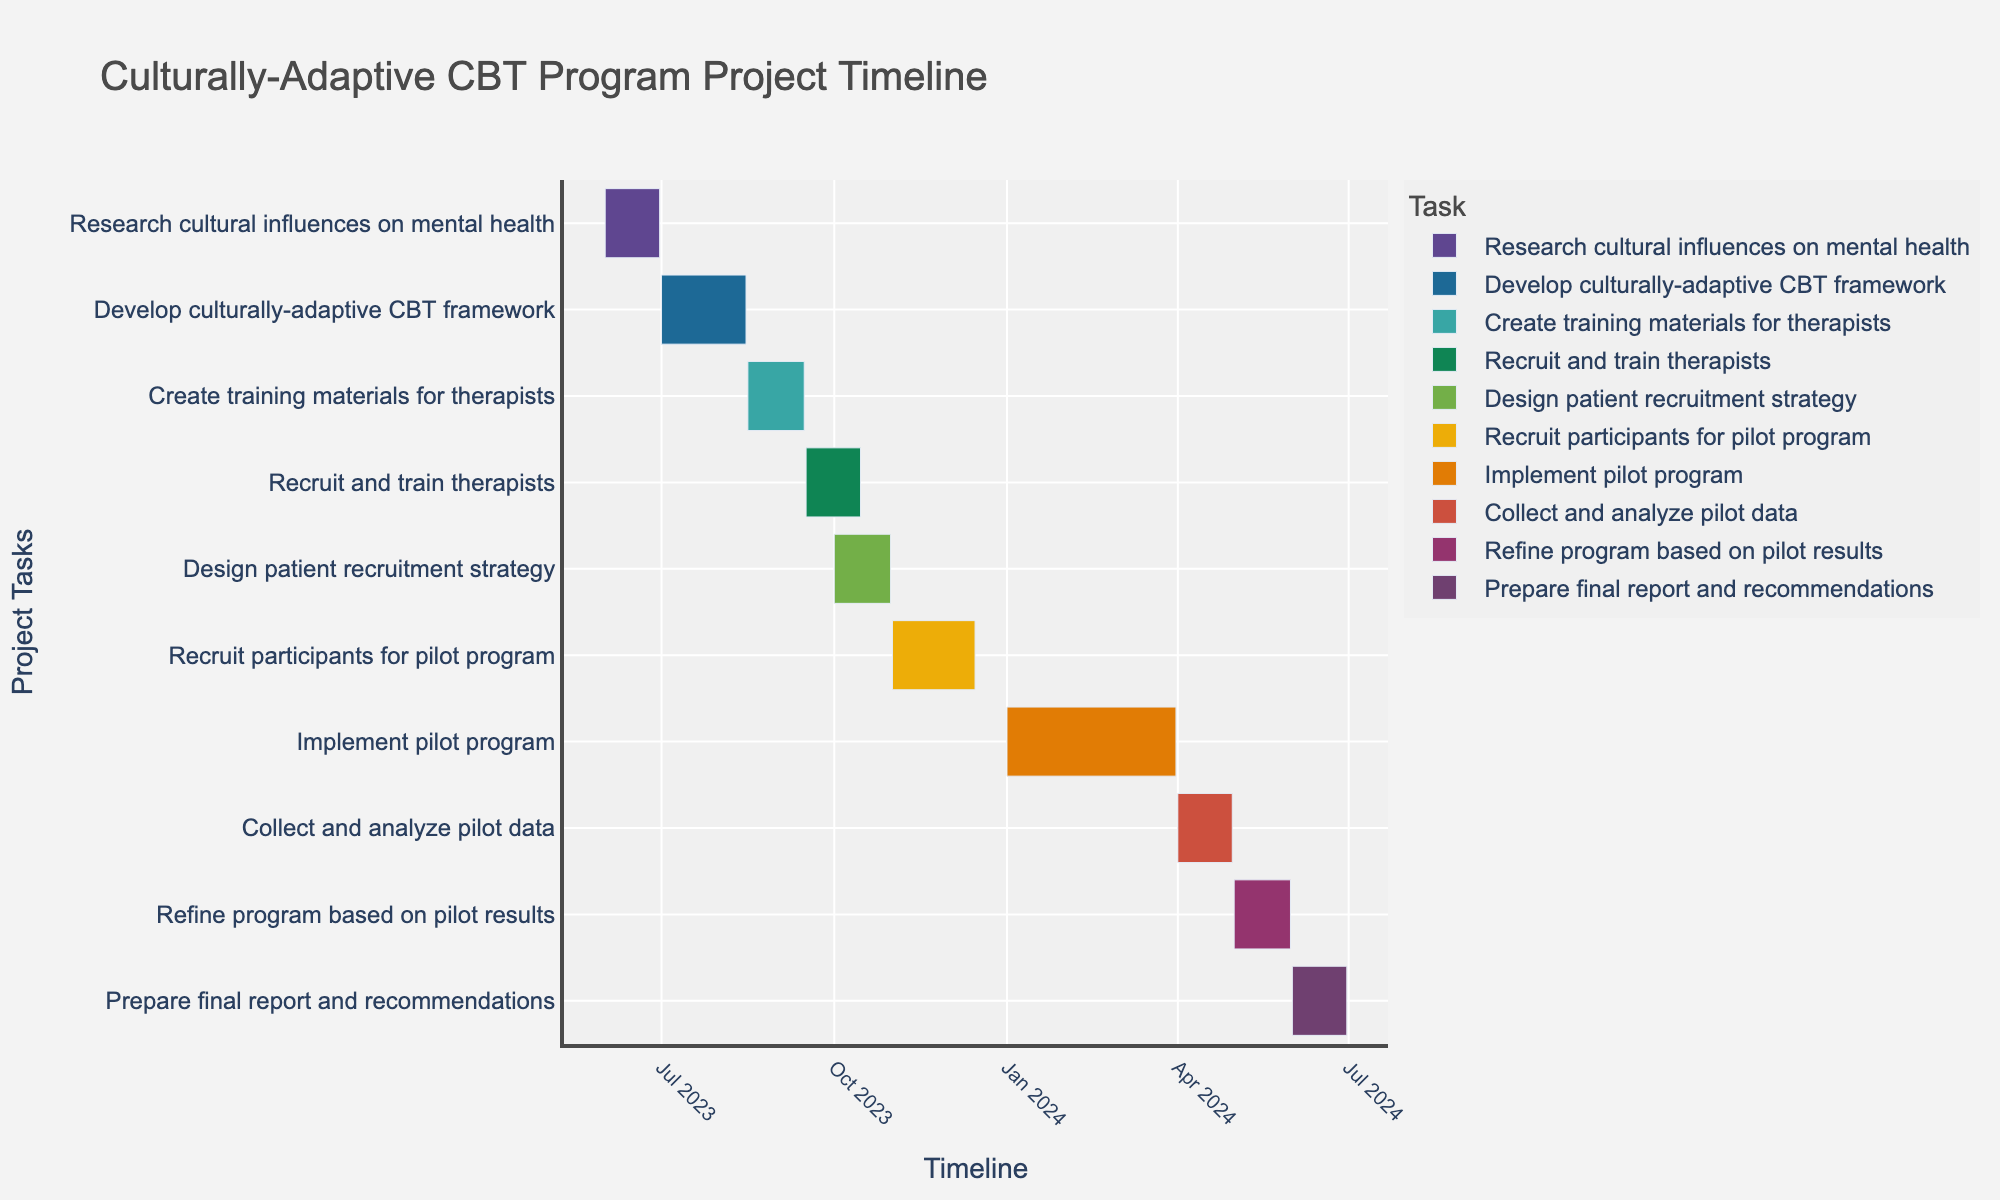How many tasks are listed in the Gantt chart? Count the number of unique tasks listed on the y-axis.
Answer: 10 Which task has the longest duration? Look at the hover information for each task to find the one with the highest number of duration days.
Answer: Implement pilot program When does the "Develop culturally-adaptive CBT framework" task end? Refer to the end date given in the hover information for this task.
Answer: August 15, 2023 How many days does it take to recruit participants for the pilot program? Check the duration given in the hover information for the task "Recruit participants for pilot program."
Answer: 45 days Which tasks overlap with the "Create training materials for therapists"? Look at the start and end dates of "Create training materials for therapists" and find other tasks with dates that fall within this range.
Answer: Develop culturally-adaptive CBT framework, Recruit and train therapists What is the total duration of time from the start of the project to the end of the "Prepare final report and recommendations" task? Calculate the duration from the start date of the first task to the end date of the last task.
Answer: 396 days Which task ends right before the "Implement pilot program" begins? Check the end dates and start dates of the tasks to see which ends just before January 1, 2024.
Answer: Recruit participants for pilot program How long after the "Recruit and train therapists" task does the "Design patient recruitment strategy" start? Calculate the number of days between the end date of "Recruit and train therapists" and the start date of "Design patient recruitment strategy."
Answer: 16 days What is the duration difference between the "Research cultural influences on mental health" task and the "Implement pilot program" task? Subtract the duration of the "Research cultural influences on mental health" task from the duration of the "Implement pilot program" task.
Answer: 61 days Which two tasks have the same duration? Compare the duration values for all tasks to find any that are equal.
Answer: Collect and analyze pilot data, Research cultural influences on mental health 